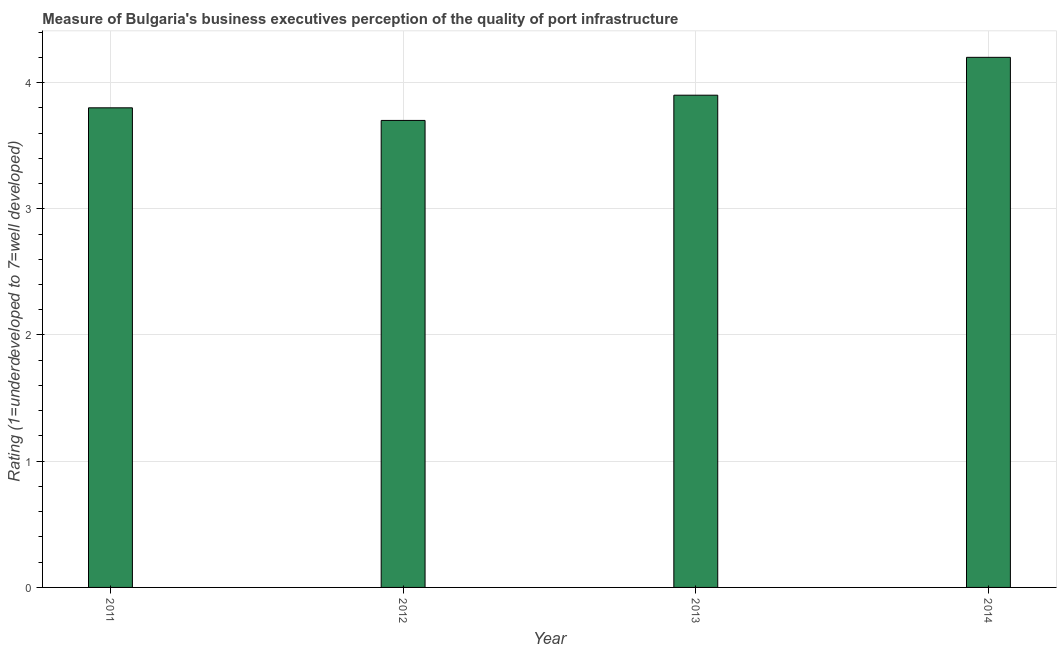Does the graph contain any zero values?
Keep it short and to the point. No. What is the title of the graph?
Provide a short and direct response. Measure of Bulgaria's business executives perception of the quality of port infrastructure. What is the label or title of the X-axis?
Give a very brief answer. Year. What is the label or title of the Y-axis?
Give a very brief answer. Rating (1=underdeveloped to 7=well developed) . Across all years, what is the maximum rating measuring quality of port infrastructure?
Provide a succinct answer. 4.2. Across all years, what is the minimum rating measuring quality of port infrastructure?
Provide a succinct answer. 3.7. In which year was the rating measuring quality of port infrastructure maximum?
Provide a succinct answer. 2014. In which year was the rating measuring quality of port infrastructure minimum?
Provide a succinct answer. 2012. What is the sum of the rating measuring quality of port infrastructure?
Offer a very short reply. 15.6. What is the difference between the rating measuring quality of port infrastructure in 2011 and 2014?
Your response must be concise. -0.4. What is the average rating measuring quality of port infrastructure per year?
Your response must be concise. 3.9. What is the median rating measuring quality of port infrastructure?
Your answer should be compact. 3.85. What is the ratio of the rating measuring quality of port infrastructure in 2011 to that in 2014?
Make the answer very short. 0.91. Is the rating measuring quality of port infrastructure in 2013 less than that in 2014?
Give a very brief answer. Yes. What is the difference between the highest and the second highest rating measuring quality of port infrastructure?
Give a very brief answer. 0.3. Is the sum of the rating measuring quality of port infrastructure in 2011 and 2013 greater than the maximum rating measuring quality of port infrastructure across all years?
Provide a succinct answer. Yes. How many bars are there?
Provide a short and direct response. 4. How many years are there in the graph?
Your answer should be very brief. 4. What is the Rating (1=underdeveloped to 7=well developed)  in 2011?
Provide a succinct answer. 3.8. What is the Rating (1=underdeveloped to 7=well developed)  in 2012?
Provide a short and direct response. 3.7. What is the Rating (1=underdeveloped to 7=well developed)  in 2013?
Ensure brevity in your answer.  3.9. What is the Rating (1=underdeveloped to 7=well developed)  in 2014?
Your response must be concise. 4.2. What is the difference between the Rating (1=underdeveloped to 7=well developed)  in 2012 and 2013?
Your answer should be compact. -0.2. What is the difference between the Rating (1=underdeveloped to 7=well developed)  in 2012 and 2014?
Your response must be concise. -0.5. What is the ratio of the Rating (1=underdeveloped to 7=well developed)  in 2011 to that in 2012?
Offer a terse response. 1.03. What is the ratio of the Rating (1=underdeveloped to 7=well developed)  in 2011 to that in 2013?
Offer a very short reply. 0.97. What is the ratio of the Rating (1=underdeveloped to 7=well developed)  in 2011 to that in 2014?
Give a very brief answer. 0.91. What is the ratio of the Rating (1=underdeveloped to 7=well developed)  in 2012 to that in 2013?
Your answer should be very brief. 0.95. What is the ratio of the Rating (1=underdeveloped to 7=well developed)  in 2012 to that in 2014?
Your response must be concise. 0.88. What is the ratio of the Rating (1=underdeveloped to 7=well developed)  in 2013 to that in 2014?
Your answer should be compact. 0.93. 